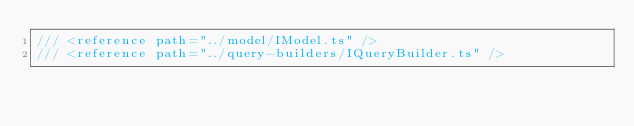<code> <loc_0><loc_0><loc_500><loc_500><_JavaScript_>/// <reference path="../model/IModel.ts" />
/// <reference path="../query-builders/IQueryBuilder.ts" />
</code> 